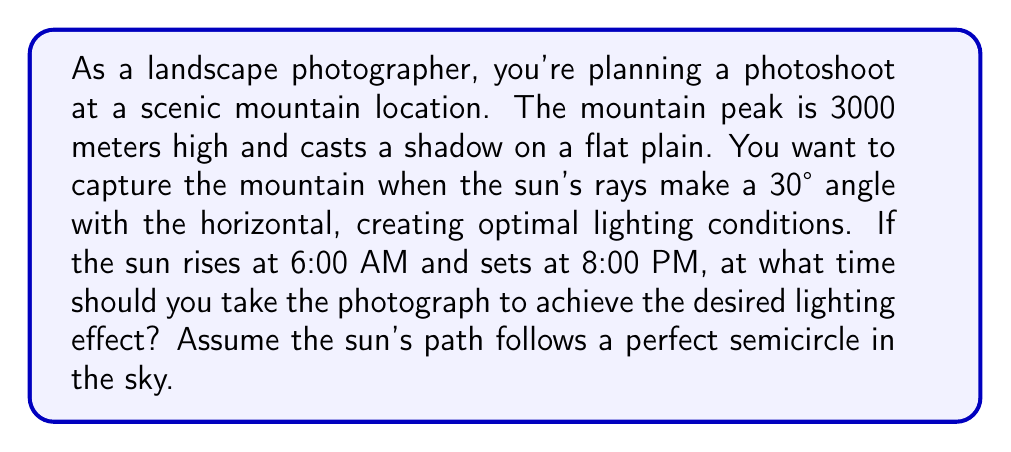Teach me how to tackle this problem. Let's approach this step-by-step:

1) First, we need to understand that the sun's path forms a semicircle from sunrise to sunset, covering 180° in 14 hours (from 6:00 AM to 8:00 PM).

2) We can calculate the sun's angular velocity:
   $$\text{Angular velocity} = \frac{180°}{14 \text{ hours}} = \frac{45°}{3.5 \text{ hours}} = \frac{15°}{\text{hour}}$$

3) At solar noon (1:00 PM, midway between sunrise and sunset), the sun is at its highest point, 90° above the horizon.

4) We want to find when the sun is at a 30° angle. This is 60° away from its highest point (90° - 30° = 60°).

5) To find the time difference from solar noon, we divide this angle by the angular velocity:
   $$\text{Time difference} = \frac{60°}{\frac{15°}{\text{hour}}} = 4 \text{ hours}$$

6) Since the sun's path is symmetrical, this time difference applies both before and after solar noon. We need the later time, so we add 4 hours to 1:00 PM.

7) Therefore, the ideal time for the photograph is 1:00 PM + 4 hours = 5:00 PM.

[asy]
import geometry;

size(200);
pair O = (0,0);
draw((-2,0)--(2,0), arrow=Arrow);
draw((0,-0.5)--(0,2), arrow=Arrow);
draw(arc(O, 2, -90, 90), blue);
draw(O--(2,0), red);
draw(O--(1.732,1), red);
label("Horizon", (2,-0.2), E);
label("Zenith", (0,2.2), N);
label("Sun's path", (1.5,1.5), NE, blue);
label("30°", (0.5,0.2), NE);
dot("O", O, SW);
</asy]
Answer: 5:00 PM 